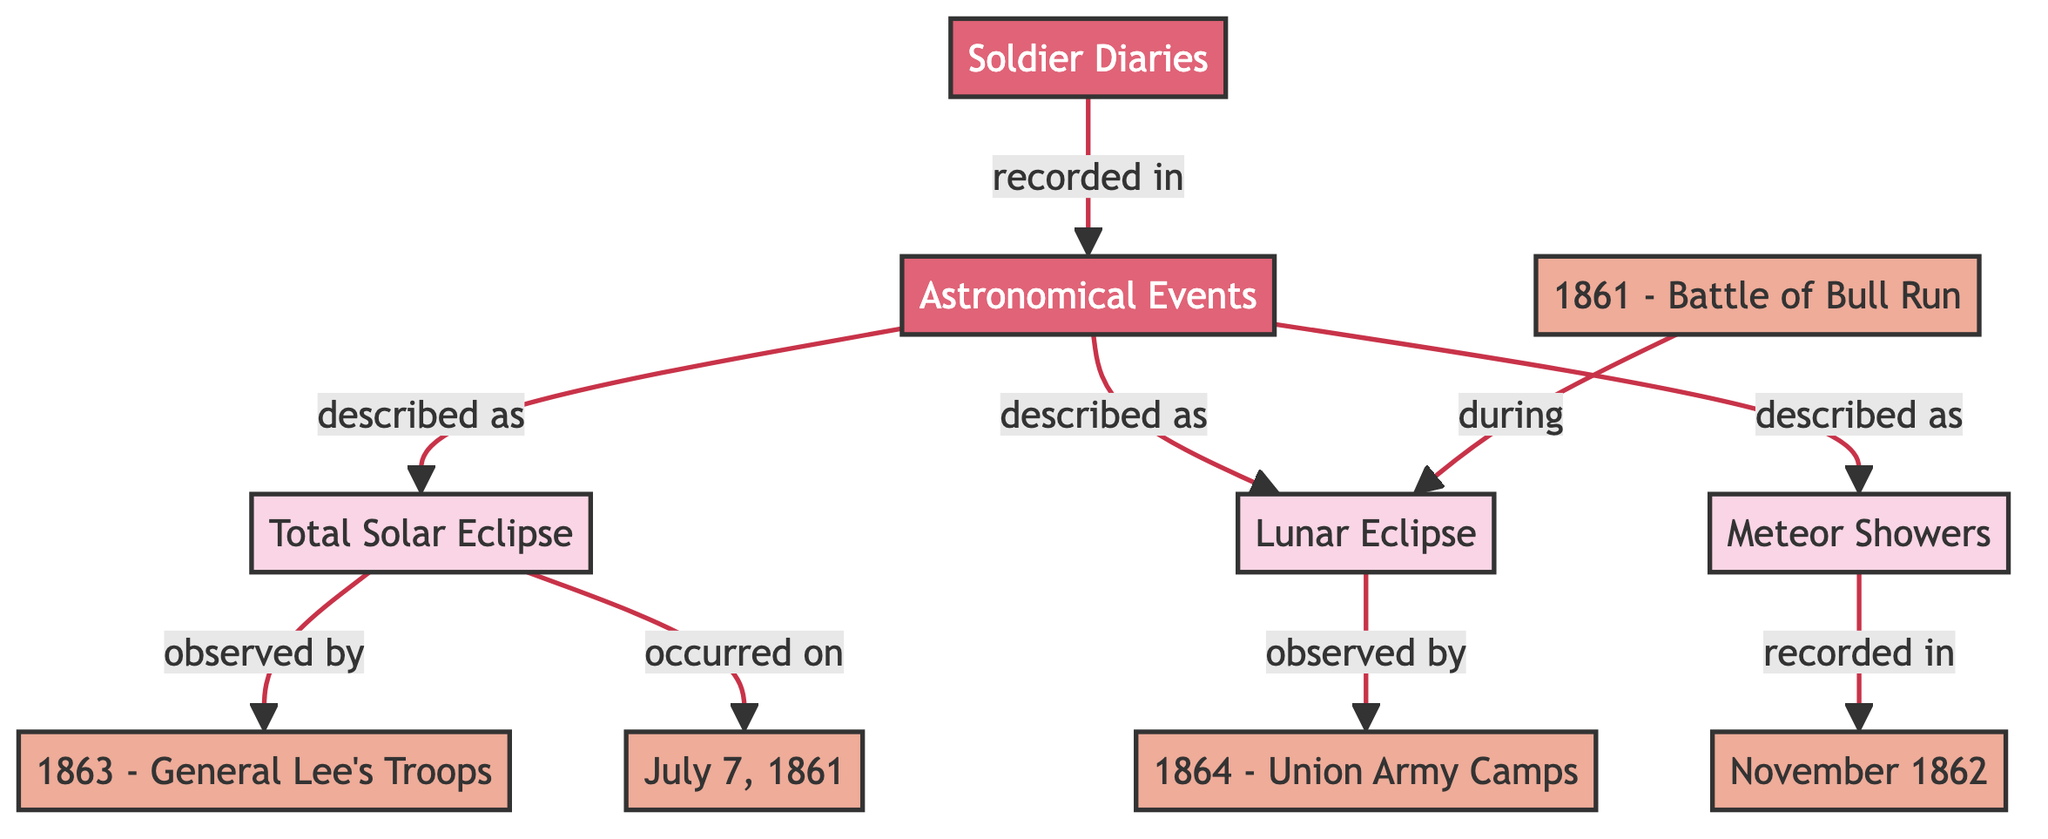What type of event is described in the diagram? The diagram describes various astronomical events as observed in soldier diaries, primarily focusing on solar eclipses, lunar eclipses, and meteor showers, classifying these under "Astronomical Events."
Answer: Astronomical Events How many soldier diary entries are shown in the diagram? The diagram indicates five diary entries, specifically those linked to soldiers during different years and events, including General Lee's troops, the Union army camps, and significant battles.
Answer: 5 What event was observed on July 7, 1861? The diagram connects the node of July 7, 1861 directly to the total solar eclipse, indicating that this specific astronomical event was recorded by soldiers during that date.
Answer: Total Solar Eclipse Which army camp observed a lunar eclipse? The diagram points out that the Union army camps in 1864 observed a lunar eclipse, linking the event to the corresponding soldier node.
Answer: Union Army Camps What event is described as occurring during the Battle of Bull Run? After analyzing the connections, the diagram depicts that the lunar eclipse was observed during the significant military engagement known as the Battle of Bull Run in 1861.
Answer: Lunar Eclipse What type of astronomical event is associated with November 1862? The diagram indicates that in November 1862, a meteor shower was recorded by soldiers, classifying it as one of the described astronomical events.
Answer: Meteor Showers Which event is directly linked to General Lee's troops? The diagram shows that General Lee's troops specifically observed the total solar eclipse, which connects this soldier node directly to the astronomical event.
Answer: Total Solar Eclipse What does the diagram represent as the main source of astronomical event recordings? The main source of astronomical event recordings in the diagram is the soldier diaries, highlighting their significance in documenting these celestial occurrences during the Civil War.
Answer: Soldier Diaries 